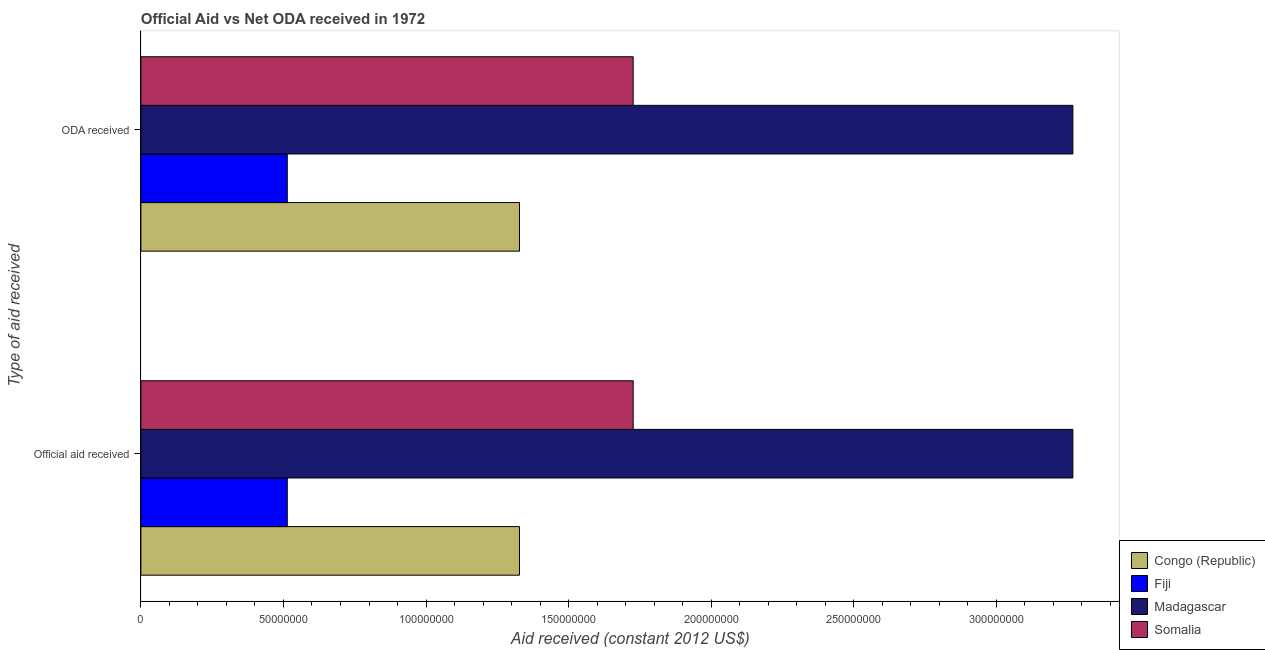How many different coloured bars are there?
Offer a terse response. 4. Are the number of bars per tick equal to the number of legend labels?
Your response must be concise. Yes. Are the number of bars on each tick of the Y-axis equal?
Your answer should be compact. Yes. How many bars are there on the 1st tick from the bottom?
Provide a succinct answer. 4. What is the label of the 2nd group of bars from the top?
Provide a short and direct response. Official aid received. What is the oda received in Fiji?
Provide a succinct answer. 5.13e+07. Across all countries, what is the maximum official aid received?
Provide a succinct answer. 3.27e+08. Across all countries, what is the minimum official aid received?
Give a very brief answer. 5.13e+07. In which country was the official aid received maximum?
Make the answer very short. Madagascar. In which country was the oda received minimum?
Your response must be concise. Fiji. What is the total official aid received in the graph?
Your answer should be very brief. 6.84e+08. What is the difference between the official aid received in Fiji and that in Madagascar?
Offer a very short reply. -2.76e+08. What is the difference between the official aid received in Fiji and the oda received in Madagascar?
Keep it short and to the point. -2.76e+08. What is the average official aid received per country?
Provide a succinct answer. 1.71e+08. What is the ratio of the oda received in Fiji to that in Madagascar?
Your answer should be very brief. 0.16. Is the official aid received in Somalia less than that in Fiji?
Your response must be concise. No. In how many countries, is the oda received greater than the average oda received taken over all countries?
Provide a succinct answer. 2. What does the 4th bar from the top in ODA received represents?
Ensure brevity in your answer.  Congo (Republic). What does the 4th bar from the bottom in ODA received represents?
Make the answer very short. Somalia. Are the values on the major ticks of X-axis written in scientific E-notation?
Your answer should be compact. No. Does the graph contain any zero values?
Offer a very short reply. No. Does the graph contain grids?
Provide a short and direct response. No. Where does the legend appear in the graph?
Offer a terse response. Bottom right. How many legend labels are there?
Offer a very short reply. 4. How are the legend labels stacked?
Give a very brief answer. Vertical. What is the title of the graph?
Offer a very short reply. Official Aid vs Net ODA received in 1972 . What is the label or title of the X-axis?
Offer a very short reply. Aid received (constant 2012 US$). What is the label or title of the Y-axis?
Keep it short and to the point. Type of aid received. What is the Aid received (constant 2012 US$) in Congo (Republic) in Official aid received?
Your answer should be very brief. 1.33e+08. What is the Aid received (constant 2012 US$) in Fiji in Official aid received?
Your response must be concise. 5.13e+07. What is the Aid received (constant 2012 US$) in Madagascar in Official aid received?
Ensure brevity in your answer.  3.27e+08. What is the Aid received (constant 2012 US$) in Somalia in Official aid received?
Keep it short and to the point. 1.73e+08. What is the Aid received (constant 2012 US$) of Congo (Republic) in ODA received?
Offer a terse response. 1.33e+08. What is the Aid received (constant 2012 US$) in Fiji in ODA received?
Provide a short and direct response. 5.13e+07. What is the Aid received (constant 2012 US$) of Madagascar in ODA received?
Make the answer very short. 3.27e+08. What is the Aid received (constant 2012 US$) in Somalia in ODA received?
Offer a very short reply. 1.73e+08. Across all Type of aid received, what is the maximum Aid received (constant 2012 US$) in Congo (Republic)?
Offer a terse response. 1.33e+08. Across all Type of aid received, what is the maximum Aid received (constant 2012 US$) of Fiji?
Provide a short and direct response. 5.13e+07. Across all Type of aid received, what is the maximum Aid received (constant 2012 US$) of Madagascar?
Your answer should be very brief. 3.27e+08. Across all Type of aid received, what is the maximum Aid received (constant 2012 US$) in Somalia?
Offer a very short reply. 1.73e+08. Across all Type of aid received, what is the minimum Aid received (constant 2012 US$) in Congo (Republic)?
Offer a terse response. 1.33e+08. Across all Type of aid received, what is the minimum Aid received (constant 2012 US$) of Fiji?
Provide a short and direct response. 5.13e+07. Across all Type of aid received, what is the minimum Aid received (constant 2012 US$) of Madagascar?
Provide a succinct answer. 3.27e+08. Across all Type of aid received, what is the minimum Aid received (constant 2012 US$) of Somalia?
Keep it short and to the point. 1.73e+08. What is the total Aid received (constant 2012 US$) of Congo (Republic) in the graph?
Your answer should be very brief. 2.66e+08. What is the total Aid received (constant 2012 US$) in Fiji in the graph?
Provide a short and direct response. 1.03e+08. What is the total Aid received (constant 2012 US$) of Madagascar in the graph?
Your answer should be very brief. 6.54e+08. What is the total Aid received (constant 2012 US$) in Somalia in the graph?
Provide a short and direct response. 3.45e+08. What is the difference between the Aid received (constant 2012 US$) in Congo (Republic) in Official aid received and that in ODA received?
Keep it short and to the point. 0. What is the difference between the Aid received (constant 2012 US$) in Madagascar in Official aid received and that in ODA received?
Offer a very short reply. 0. What is the difference between the Aid received (constant 2012 US$) of Congo (Republic) in Official aid received and the Aid received (constant 2012 US$) of Fiji in ODA received?
Provide a short and direct response. 8.14e+07. What is the difference between the Aid received (constant 2012 US$) in Congo (Republic) in Official aid received and the Aid received (constant 2012 US$) in Madagascar in ODA received?
Your answer should be very brief. -1.94e+08. What is the difference between the Aid received (constant 2012 US$) of Congo (Republic) in Official aid received and the Aid received (constant 2012 US$) of Somalia in ODA received?
Offer a very short reply. -3.99e+07. What is the difference between the Aid received (constant 2012 US$) in Fiji in Official aid received and the Aid received (constant 2012 US$) in Madagascar in ODA received?
Your answer should be compact. -2.76e+08. What is the difference between the Aid received (constant 2012 US$) of Fiji in Official aid received and the Aid received (constant 2012 US$) of Somalia in ODA received?
Your answer should be compact. -1.21e+08. What is the difference between the Aid received (constant 2012 US$) in Madagascar in Official aid received and the Aid received (constant 2012 US$) in Somalia in ODA received?
Make the answer very short. 1.54e+08. What is the average Aid received (constant 2012 US$) of Congo (Republic) per Type of aid received?
Provide a short and direct response. 1.33e+08. What is the average Aid received (constant 2012 US$) of Fiji per Type of aid received?
Make the answer very short. 5.13e+07. What is the average Aid received (constant 2012 US$) of Madagascar per Type of aid received?
Make the answer very short. 3.27e+08. What is the average Aid received (constant 2012 US$) of Somalia per Type of aid received?
Your response must be concise. 1.73e+08. What is the difference between the Aid received (constant 2012 US$) in Congo (Republic) and Aid received (constant 2012 US$) in Fiji in Official aid received?
Give a very brief answer. 8.14e+07. What is the difference between the Aid received (constant 2012 US$) of Congo (Republic) and Aid received (constant 2012 US$) of Madagascar in Official aid received?
Your answer should be very brief. -1.94e+08. What is the difference between the Aid received (constant 2012 US$) of Congo (Republic) and Aid received (constant 2012 US$) of Somalia in Official aid received?
Provide a succinct answer. -3.99e+07. What is the difference between the Aid received (constant 2012 US$) in Fiji and Aid received (constant 2012 US$) in Madagascar in Official aid received?
Provide a short and direct response. -2.76e+08. What is the difference between the Aid received (constant 2012 US$) in Fiji and Aid received (constant 2012 US$) in Somalia in Official aid received?
Provide a succinct answer. -1.21e+08. What is the difference between the Aid received (constant 2012 US$) in Madagascar and Aid received (constant 2012 US$) in Somalia in Official aid received?
Your answer should be compact. 1.54e+08. What is the difference between the Aid received (constant 2012 US$) of Congo (Republic) and Aid received (constant 2012 US$) of Fiji in ODA received?
Offer a very short reply. 8.14e+07. What is the difference between the Aid received (constant 2012 US$) of Congo (Republic) and Aid received (constant 2012 US$) of Madagascar in ODA received?
Offer a very short reply. -1.94e+08. What is the difference between the Aid received (constant 2012 US$) of Congo (Republic) and Aid received (constant 2012 US$) of Somalia in ODA received?
Keep it short and to the point. -3.99e+07. What is the difference between the Aid received (constant 2012 US$) in Fiji and Aid received (constant 2012 US$) in Madagascar in ODA received?
Your response must be concise. -2.76e+08. What is the difference between the Aid received (constant 2012 US$) of Fiji and Aid received (constant 2012 US$) of Somalia in ODA received?
Provide a succinct answer. -1.21e+08. What is the difference between the Aid received (constant 2012 US$) of Madagascar and Aid received (constant 2012 US$) of Somalia in ODA received?
Your answer should be compact. 1.54e+08. What is the ratio of the Aid received (constant 2012 US$) in Somalia in Official aid received to that in ODA received?
Your response must be concise. 1. What is the difference between the highest and the second highest Aid received (constant 2012 US$) in Congo (Republic)?
Provide a short and direct response. 0. What is the difference between the highest and the second highest Aid received (constant 2012 US$) of Fiji?
Keep it short and to the point. 0. What is the difference between the highest and the second highest Aid received (constant 2012 US$) of Madagascar?
Provide a succinct answer. 0. What is the difference between the highest and the second highest Aid received (constant 2012 US$) of Somalia?
Provide a short and direct response. 0. What is the difference between the highest and the lowest Aid received (constant 2012 US$) in Fiji?
Ensure brevity in your answer.  0. What is the difference between the highest and the lowest Aid received (constant 2012 US$) of Madagascar?
Provide a short and direct response. 0. What is the difference between the highest and the lowest Aid received (constant 2012 US$) of Somalia?
Make the answer very short. 0. 